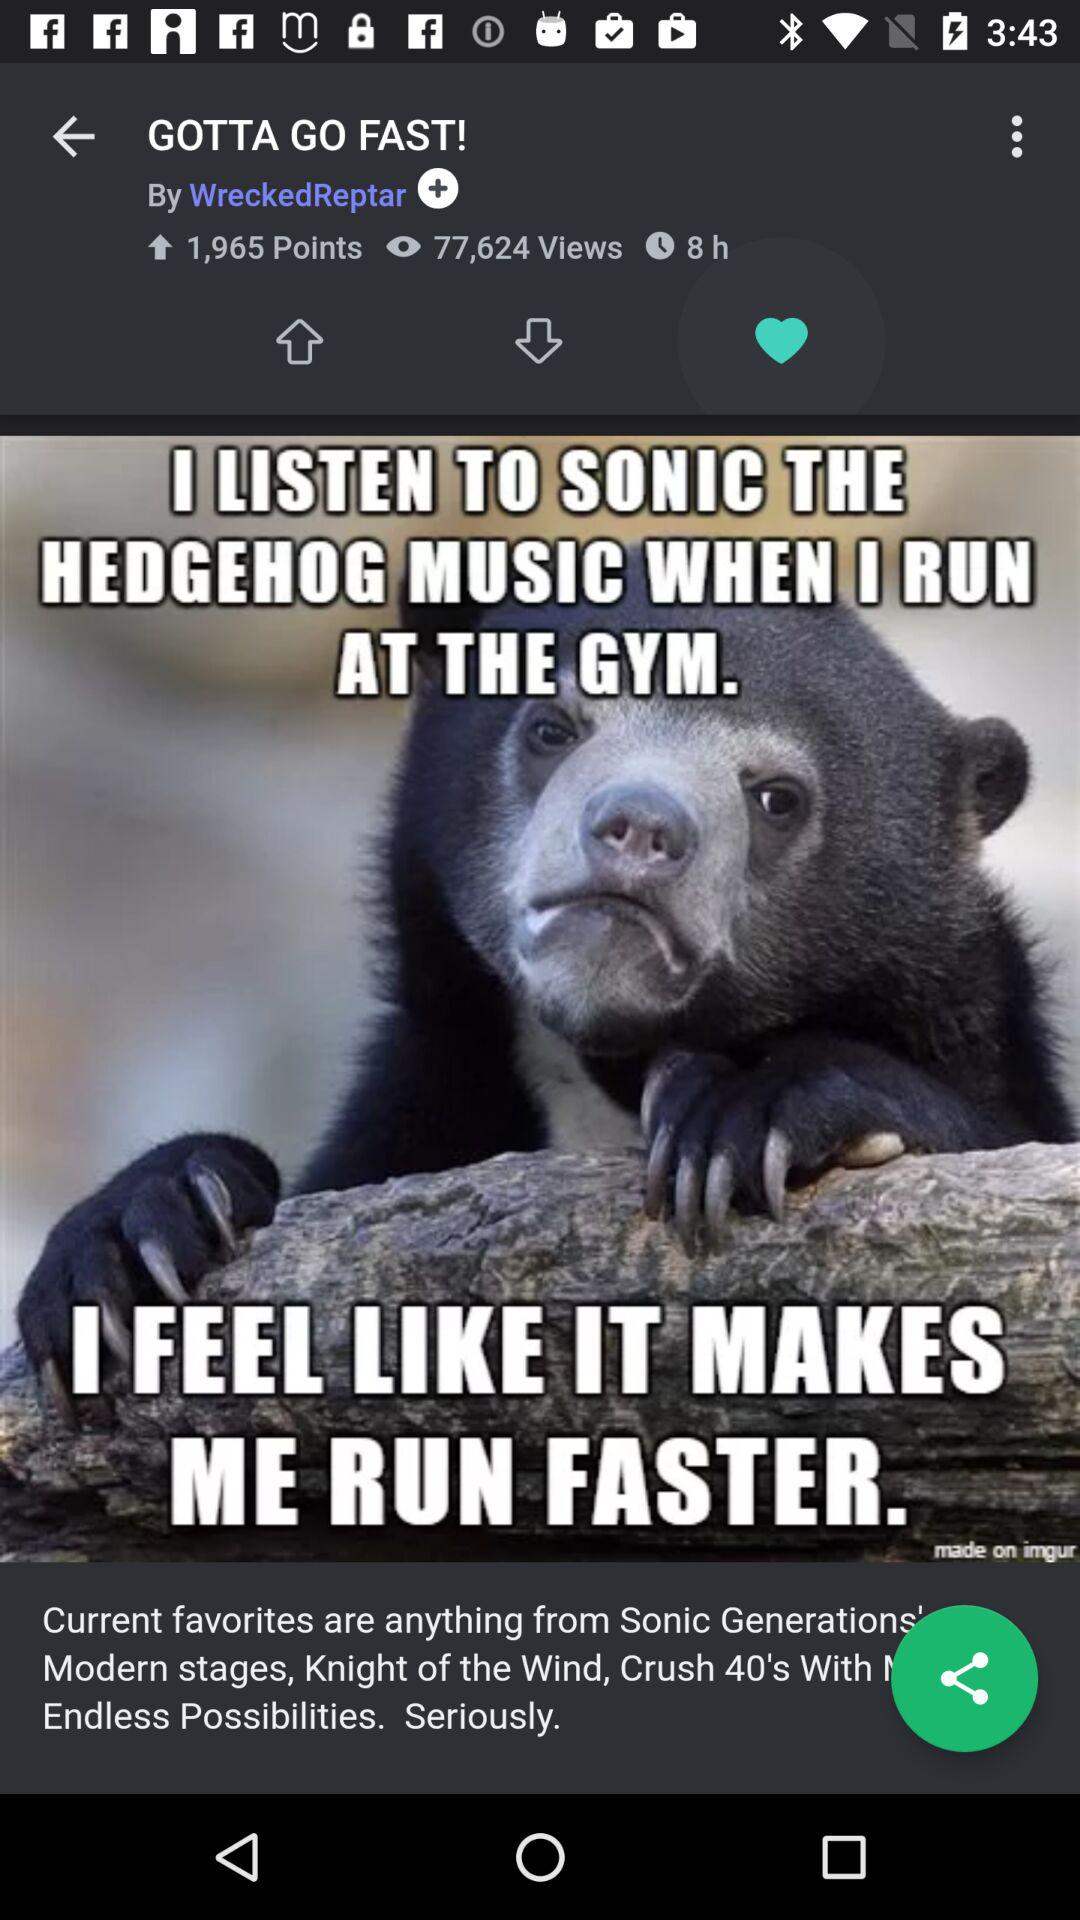Who posted this picture? This picture was posted by "WreckedReptar". 